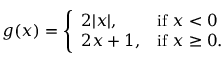Convert formula to latex. <formula><loc_0><loc_0><loc_500><loc_500>g ( x ) = { \left \{ \begin{array} { l l } { 2 | x | , } & { { i f } x < 0 } \\ { 2 x + 1 , } & { { i f } x \geq 0 . } \end{array} }</formula> 